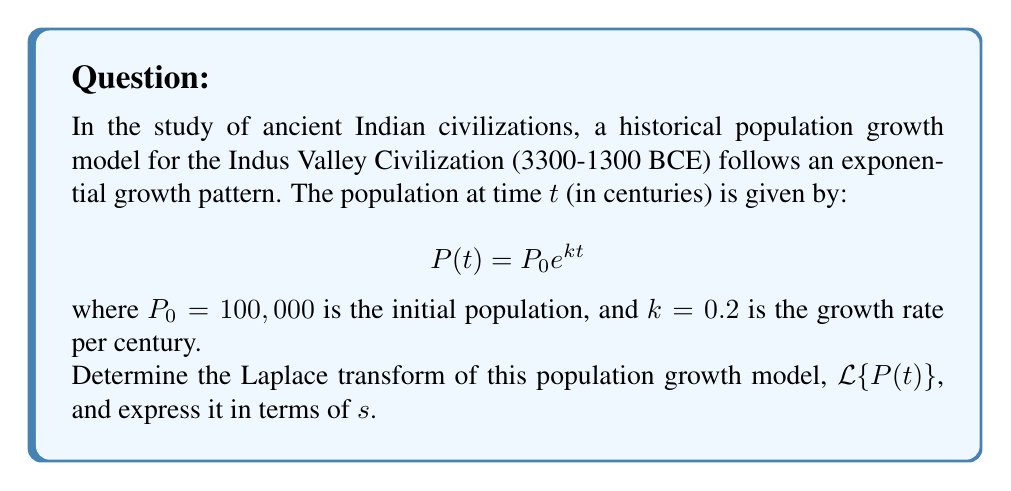Show me your answer to this math problem. To solve this problem, we'll follow these steps:

1) Recall the Laplace transform of the exponential function:
   $$\mathcal{L}\{e^{at}\} = \frac{1}{s-a}$$

2) In our case, $P(t) = P_0 e^{kt}$, where $P_0 = 100,000$ and $k = 0.2$

3) Apply the Laplace transform:
   $$\mathcal{L}\{P(t)\} = \mathcal{L}\{P_0 e^{kt}\}$$

4) Use the linearity property of Laplace transforms:
   $$\mathcal{L}\{P(t)\} = P_0 \mathcal{L}\{e^{kt}\}$$

5) Apply the formula from step 1:
   $$\mathcal{L}\{P(t)\} = P_0 \cdot \frac{1}{s-k}$$

6) Substitute the values:
   $$\mathcal{L}\{P(t)\} = 100,000 \cdot \frac{1}{s-0.2}$$

7) Simplify:
   $$\mathcal{L}\{P(t)\} = \frac{100,000}{s-0.2}$$

Thus, we have derived the Laplace transform of the historical population growth model for the Indus Valley Civilization.
Answer: $$\mathcal{L}\{P(t)\} = \frac{100,000}{s-0.2}$$ 